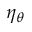Convert formula to latex. <formula><loc_0><loc_0><loc_500><loc_500>\eta _ { \theta }</formula> 